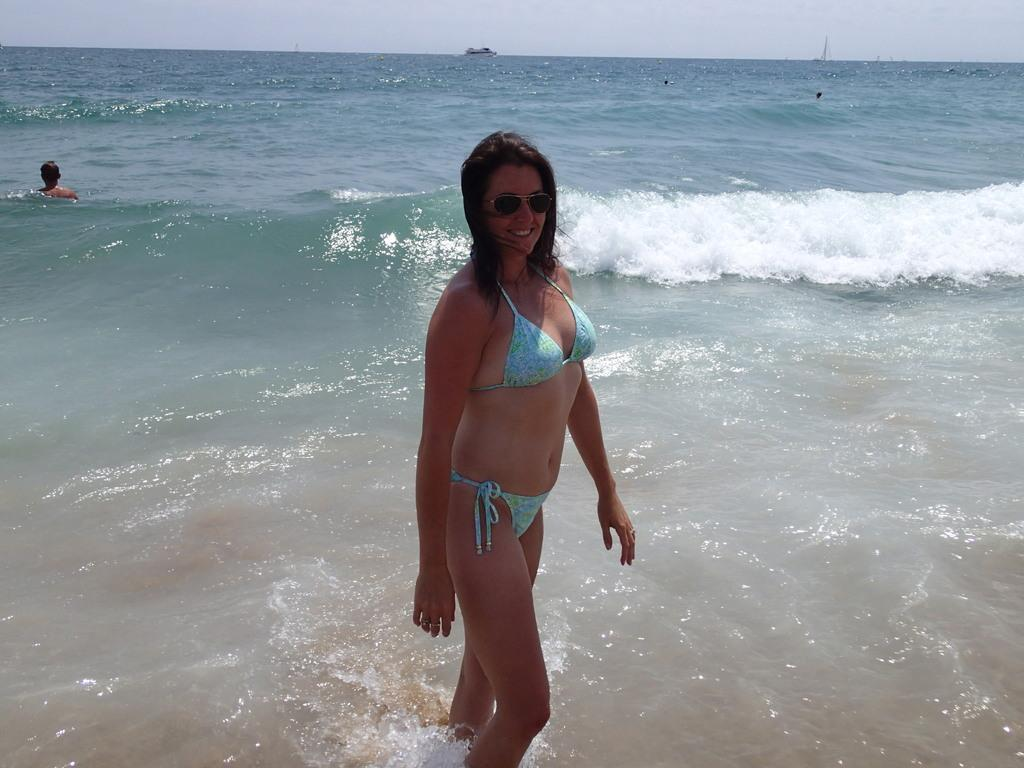What is the primary subject of the image? There is a woman in the image. What is the woman doing in the image? The woman is standing in the water. What is the woman's facial expression in the image? The woman is smiling. What is the woman wearing in the image? The woman is wearing goggles. What can be seen in the background of the image? There is a sea in the background of the image. Are there any other people in the water? Yes, there is a person in the water. What type of fear can be seen on the woman's face in the image? The woman is smiling in the image, so there is no fear visible on her face. 